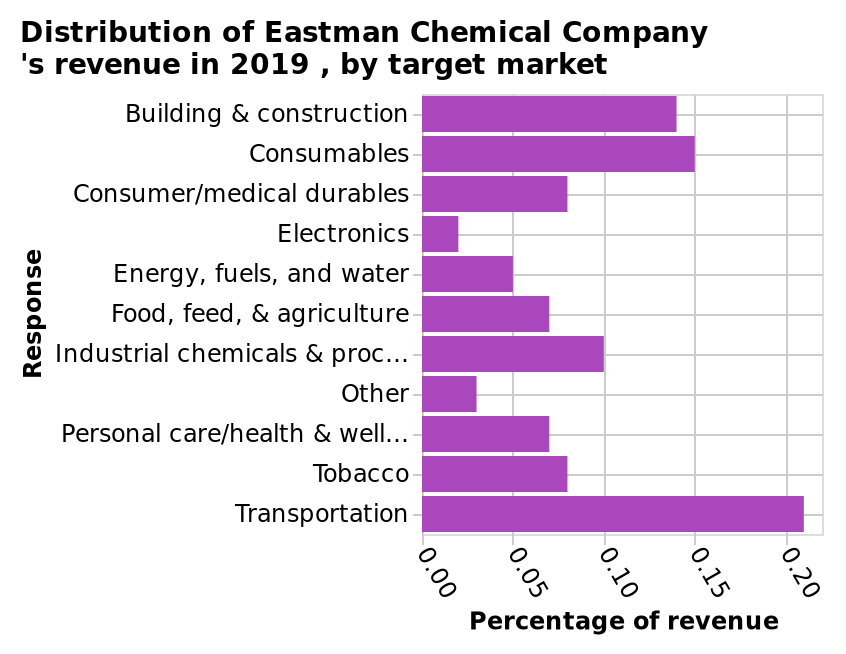<image>
What company's revenue is depicted in the bar chart? The bar chart depicts the revenue of Eastman Chemical Company in 2019. What is the title of the bar chart? The title of the bar chart is "Distribution of Eastman Chemical Company's revenue in 2019, by target market." What percentage of revenue is spent on transportation? Approximately 21% is spent on transportation. Which category has the lowest percentage of revenue spent on? Electronics with approximately 2%. 